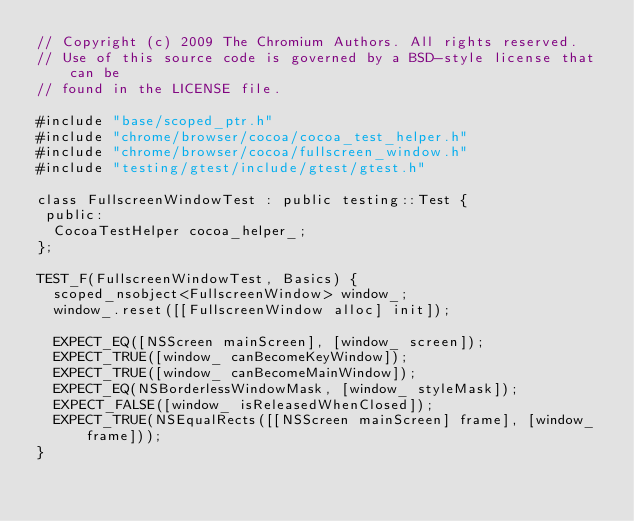<code> <loc_0><loc_0><loc_500><loc_500><_ObjectiveC_>// Copyright (c) 2009 The Chromium Authors. All rights reserved.
// Use of this source code is governed by a BSD-style license that can be
// found in the LICENSE file.

#include "base/scoped_ptr.h"
#include "chrome/browser/cocoa/cocoa_test_helper.h"
#include "chrome/browser/cocoa/fullscreen_window.h"
#include "testing/gtest/include/gtest/gtest.h"

class FullscreenWindowTest : public testing::Test {
 public:
  CocoaTestHelper cocoa_helper_;
};

TEST_F(FullscreenWindowTest, Basics) {
  scoped_nsobject<FullscreenWindow> window_;
  window_.reset([[FullscreenWindow alloc] init]);

  EXPECT_EQ([NSScreen mainScreen], [window_ screen]);
  EXPECT_TRUE([window_ canBecomeKeyWindow]);
  EXPECT_TRUE([window_ canBecomeMainWindow]);
  EXPECT_EQ(NSBorderlessWindowMask, [window_ styleMask]);
  EXPECT_FALSE([window_ isReleasedWhenClosed]);
  EXPECT_TRUE(NSEqualRects([[NSScreen mainScreen] frame], [window_ frame]));
}


</code> 